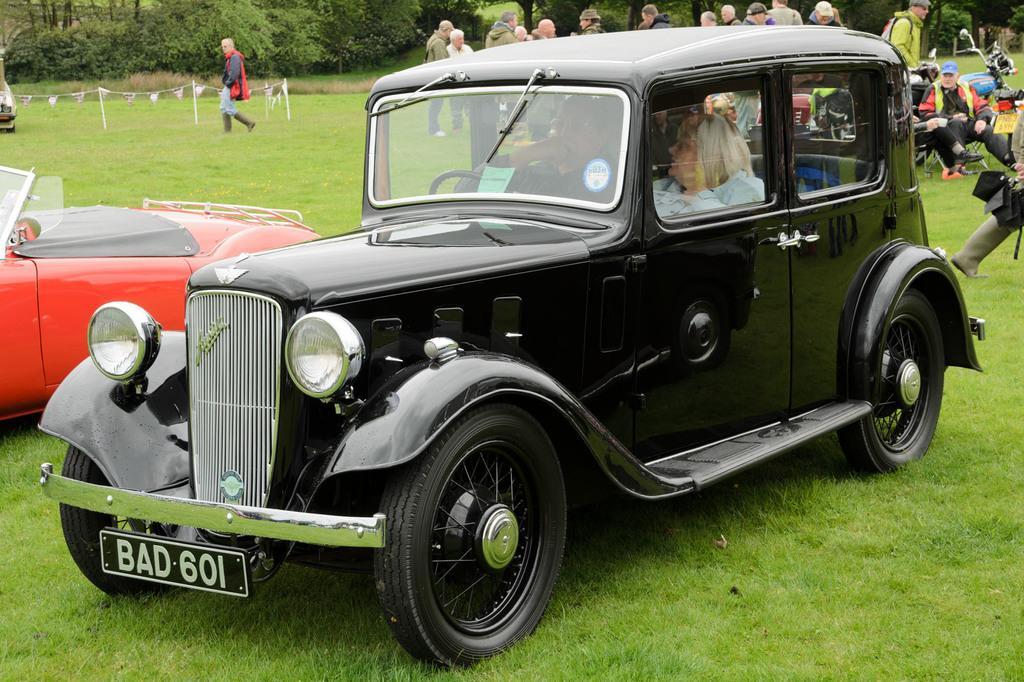In one or two sentences, can you explain what this image depicts? This picture contain black jeep which is placed in front of the picture and beside this, we see a red car and behind this jeep we see many people standing. We even see a blue color bike. On the top of the picture, we see many trees and on the bottom of the picture, we see grass. Man in red jacket is walking on the grass. 